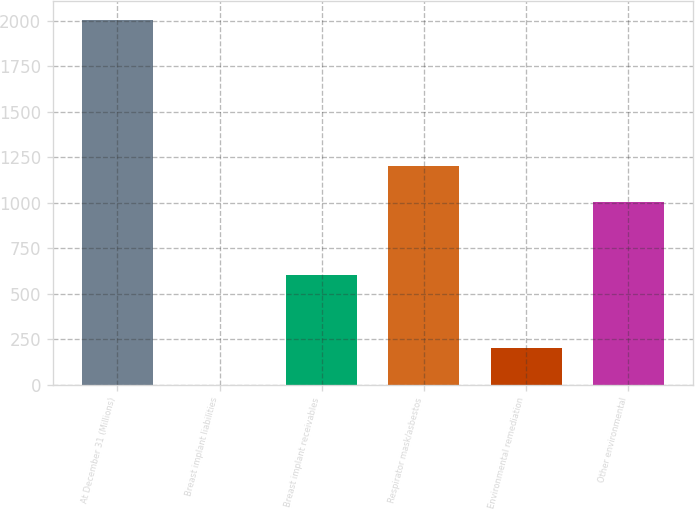<chart> <loc_0><loc_0><loc_500><loc_500><bar_chart><fcel>At December 31 (Millions)<fcel>Breast implant liabilities<fcel>Breast implant receivables<fcel>Respirator mask/asbestos<fcel>Environmental remediation<fcel>Other environmental<nl><fcel>2007<fcel>1<fcel>602.8<fcel>1204.6<fcel>201.6<fcel>1004<nl></chart> 